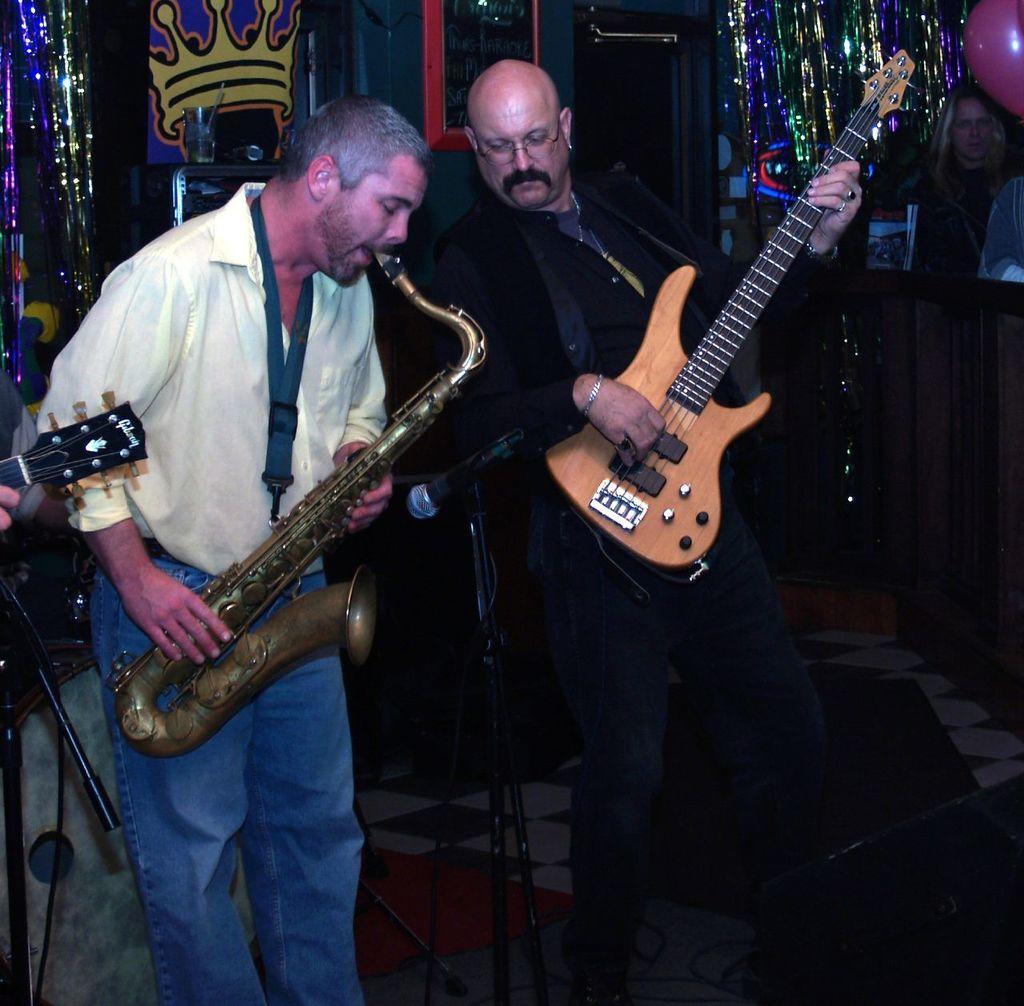How would you summarize this image in a sentence or two? There are people playing musical instrument as we can see in the middle of this image. We can see a decoration in the background. There are Mics at the bottom of this image. The person standing in the middle is holding a guitar. 